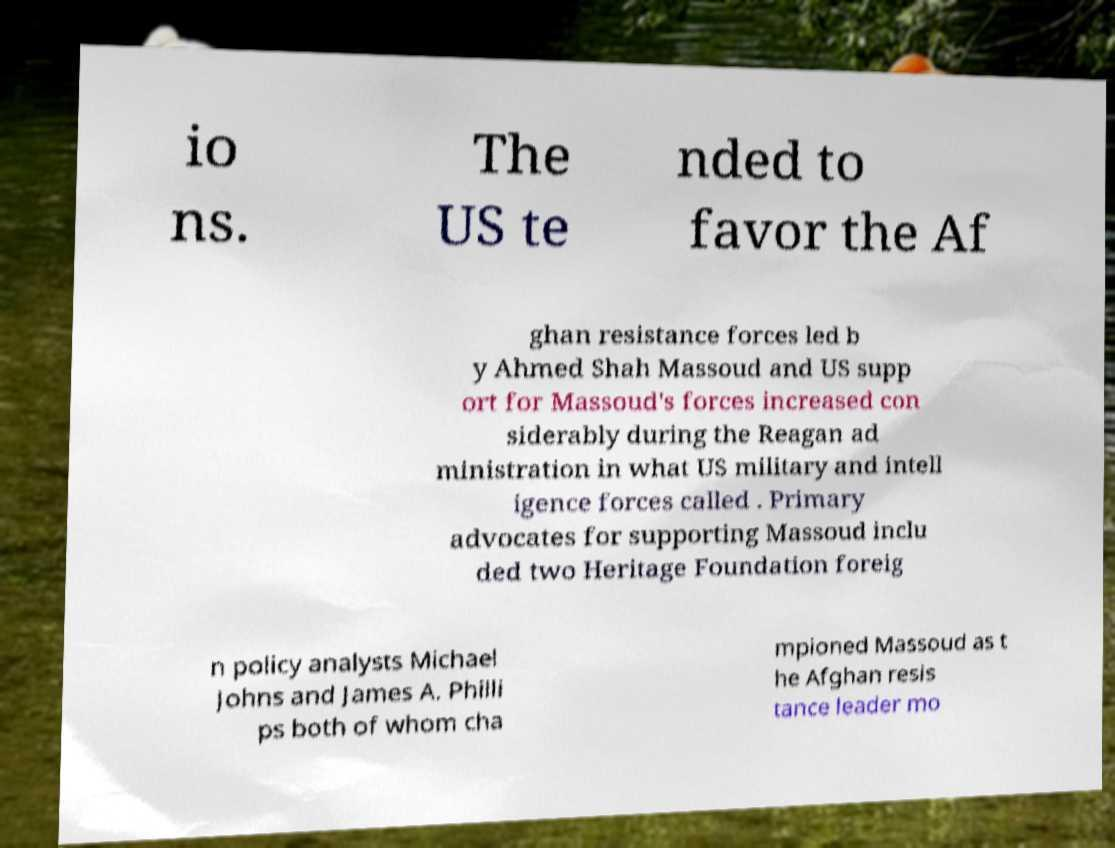Could you extract and type out the text from this image? io ns. The US te nded to favor the Af ghan resistance forces led b y Ahmed Shah Massoud and US supp ort for Massoud's forces increased con siderably during the Reagan ad ministration in what US military and intell igence forces called . Primary advocates for supporting Massoud inclu ded two Heritage Foundation foreig n policy analysts Michael Johns and James A. Philli ps both of whom cha mpioned Massoud as t he Afghan resis tance leader mo 